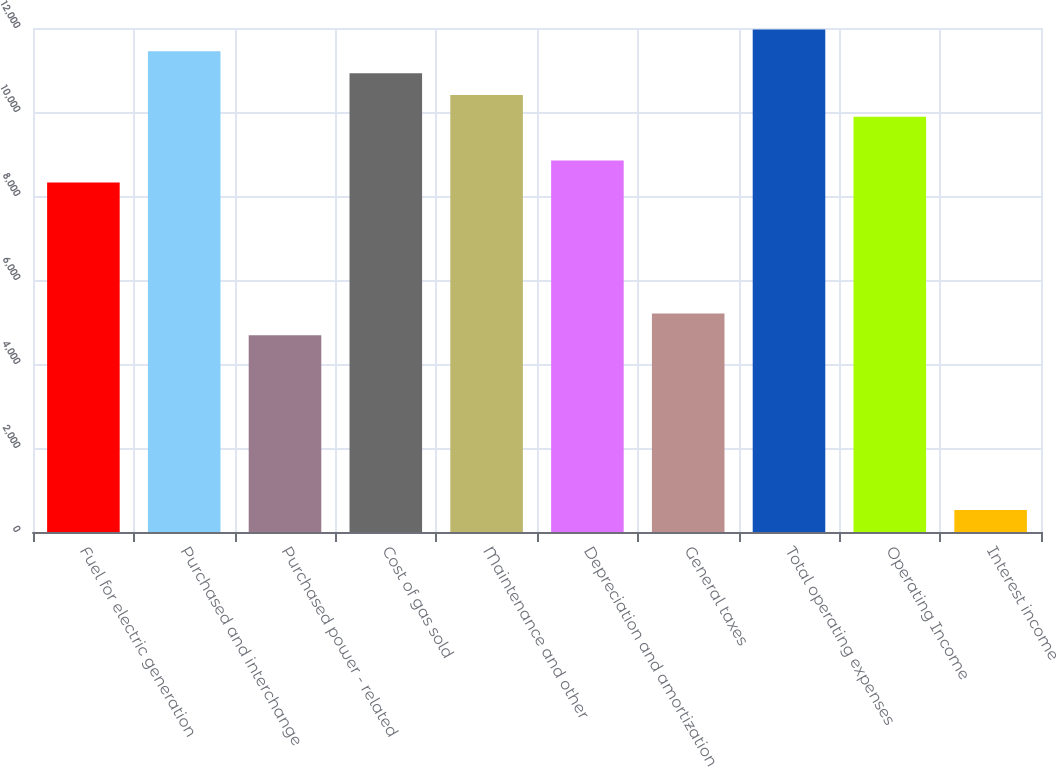Convert chart to OTSL. <chart><loc_0><loc_0><loc_500><loc_500><bar_chart><fcel>Fuel for electric generation<fcel>Purchased and interchange<fcel>Purchased power - related<fcel>Cost of gas sold<fcel>Maintenance and other<fcel>Depreciation and amortization<fcel>General taxes<fcel>Total operating expenses<fcel>Operating Income<fcel>Interest income<nl><fcel>8324.2<fcel>11445.4<fcel>4682.8<fcel>10925.2<fcel>10405<fcel>8844.4<fcel>5203<fcel>11965.6<fcel>9884.8<fcel>521.2<nl></chart> 